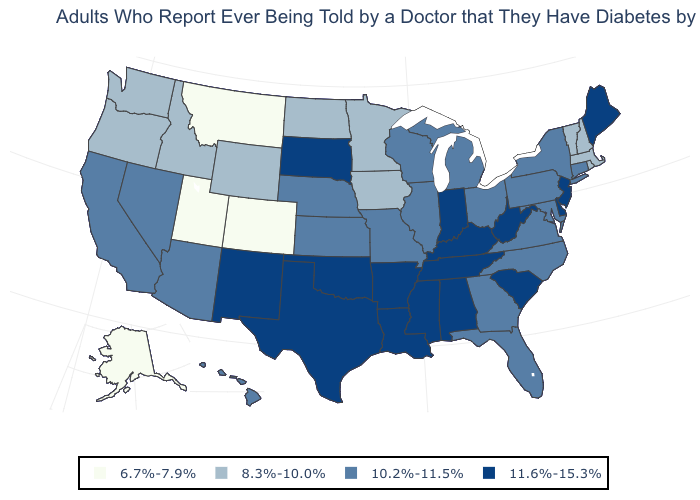Does Indiana have the highest value in the MidWest?
Be succinct. Yes. Among the states that border Rhode Island , which have the lowest value?
Answer briefly. Massachusetts. What is the highest value in the MidWest ?
Give a very brief answer. 11.6%-15.3%. Among the states that border Maryland , does West Virginia have the lowest value?
Write a very short answer. No. What is the highest value in the USA?
Concise answer only. 11.6%-15.3%. Among the states that border Iowa , does South Dakota have the lowest value?
Quick response, please. No. Which states have the highest value in the USA?
Be succinct. Alabama, Arkansas, Delaware, Indiana, Kentucky, Louisiana, Maine, Mississippi, New Jersey, New Mexico, Oklahoma, South Carolina, South Dakota, Tennessee, Texas, West Virginia. What is the value of Pennsylvania?
Quick response, please. 10.2%-11.5%. Does Indiana have the highest value in the MidWest?
Give a very brief answer. Yes. What is the value of Colorado?
Answer briefly. 6.7%-7.9%. What is the value of South Carolina?
Write a very short answer. 11.6%-15.3%. Does Alabama have the highest value in the USA?
Write a very short answer. Yes. Name the states that have a value in the range 11.6%-15.3%?
Keep it brief. Alabama, Arkansas, Delaware, Indiana, Kentucky, Louisiana, Maine, Mississippi, New Jersey, New Mexico, Oklahoma, South Carolina, South Dakota, Tennessee, Texas, West Virginia. Among the states that border Alabama , does Mississippi have the lowest value?
Write a very short answer. No. 